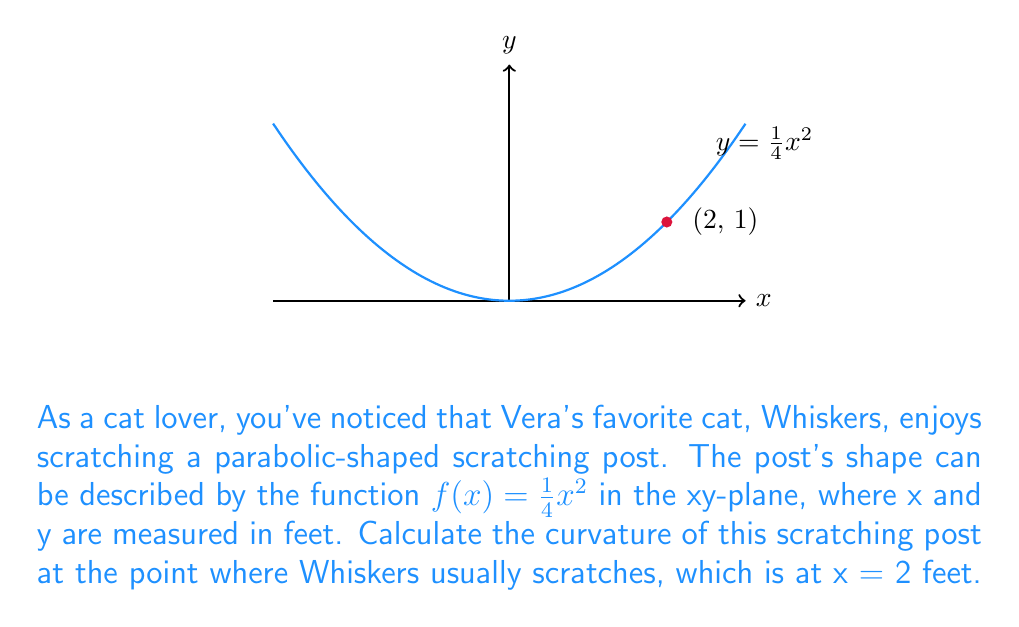Show me your answer to this math problem. Let's approach this step-by-step:

1) The curvature κ of a curve y = f(x) at any point is given by the formula:

   $$\kappa = \frac{|f''(x)|}{(1 + [f'(x)]^2)^{3/2}}$$

2) We need to find f'(x) and f''(x):
   
   $f(x) = \frac{1}{4}x^2$
   $f'(x) = \frac{1}{2}x$
   $f''(x) = \frac{1}{2}$

3) At x = 2:
   
   $f'(2) = 1$
   $f''(2) = \frac{1}{2}$

4) Now, let's substitute these values into the curvature formula:

   $$\kappa = \frac{|\frac{1}{2}|}{(1 + [1]^2)^{3/2}}$$

5) Simplify:
   
   $$\kappa = \frac{0.5}{(1 + 1)^{3/2}} = \frac{0.5}{2^{3/2}} = \frac{0.5}{2\sqrt{2}}$$

6) This can be further simplified:

   $$\kappa = \frac{1}{4\sqrt{2}} \approx 0.1768$$

Thus, the curvature of the scratching post at x = 2 feet is $\frac{1}{4\sqrt{2}}$ ft⁻¹.
Answer: $\frac{1}{4\sqrt{2}}$ ft⁻¹ 